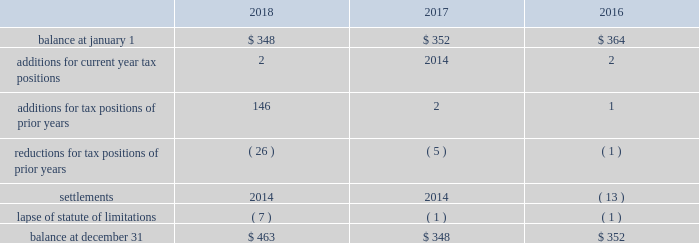The aes corporation notes to consolidated financial statements 2014 ( continued ) december 31 , 2018 , 2017 , and 2016 the following is a reconciliation of the beginning and ending amounts of unrecognized tax benefits for the periods indicated ( in millions ) : .
The company and certain of its subsidiaries are currently under examination by the relevant taxing authorities for various tax years .
The company regularly assesses the potential outcome of these examinations in each of the taxing jurisdictions when determining the adequacy of the amount of unrecognized tax benefit recorded .
While it is often difficult to predict the final outcome or the timing of resolution of any particular uncertain tax position , we believe we have appropriately accrued for our uncertain tax benefits .
However , audit outcomes and the timing of audit settlements and future events that would impact our previously recorded unrecognized tax benefits and the range of anticipated increases or decreases in unrecognized tax benefits are subject to significant uncertainty .
It is possible that the ultimate outcome of current or future examinations may exceed our provision for current unrecognized tax benefits in amounts that could be material , but cannot be estimated as of december 31 , 2018 .
Our effective tax rate and net income in any given future period could therefore be materially impacted .
22 .
Discontinued operations due to a portfolio evaluation in the first half of 2016 , management decided to pursue a strategic shift of its distribution companies in brazil , sul and eletropaulo , to reduce the company's exposure to the brazilian distribution market .
The disposals of sul and eletropaulo were completed in october 2016 and june 2018 , respectively .
Eletropaulo 2014 in november 2017 , eletropaulo converted its preferred shares into ordinary shares and transitioned the listing of those shares to the novo mercado , which is a listing segment of the brazilian stock exchange with the highest standards of corporate governance .
Upon conversion of the preferred shares into ordinary shares , aes no longer controlled eletropaulo , but maintained significant influence over the business .
As a result , the company deconsolidated eletropaulo .
After deconsolidation , the company's 17% ( 17 % ) ownership interest was reflected as an equity method investment .
The company recorded an after-tax loss on deconsolidation of $ 611 million , which primarily consisted of $ 455 million related to cumulative translation losses and $ 243 million related to pension losses reclassified from aocl .
In december 2017 , all the remaining criteria were met for eletropaulo to qualify as a discontinued operation .
Therefore , its results of operations and financial position were reported as such in the consolidated financial statements for all periods presented .
In june 2018 , the company completed the sale of its entire 17% ( 17 % ) ownership interest in eletropaulo through a bidding process hosted by the brazilian securities regulator , cvm .
Gross proceeds of $ 340 million were received at our subsidiary in brazil , subject to the payment of taxes .
Upon disposal of eletropaulo , the company recorded a pre-tax gain on sale of $ 243 million ( after-tax $ 199 million ) .
Excluding the gain on sale , eletropaulo's pre-tax loss attributable to aes was immaterial for the year ended december 31 , 2018 .
Eletropaulo's pre-tax loss attributable to aes , including the loss on deconsolidation , for the years ended december 31 , 2017 and 2016 was $ 633 million and $ 192 million , respectively .
Prior to its classification as discontinued operations , eletropaulo was reported in the south america sbu reportable segment .
Sul 2014 the company executed an agreement for the sale of sul , a wholly-owned subsidiary , in june 2016 .
The results of operations and financial position of sul are reported as discontinued operations in the consolidated financial statements for all periods presented .
Upon meeting the held-for-sale criteria , the company recognized an after-tax loss of $ 382 million comprised of a pre-tax impairment charge of $ 783 million , offset by a tax benefit of $ 266 million related to the impairment of the sul long lived assets and a tax benefit of $ 135 million for deferred taxes related to the investment in sul .
Prior to the impairment charge , the carrying value of the sul asset group of $ 1.6 billion was greater than its approximate fair value less costs to sell .
However , the impairment charge was limited to the carrying value of the long lived assets of the sul disposal group. .
What was the percentage change of unrecognized tax benefits at year end between 2017 and 2018? 
Computations: ((463 - 348) / 348)
Answer: 0.33046. 